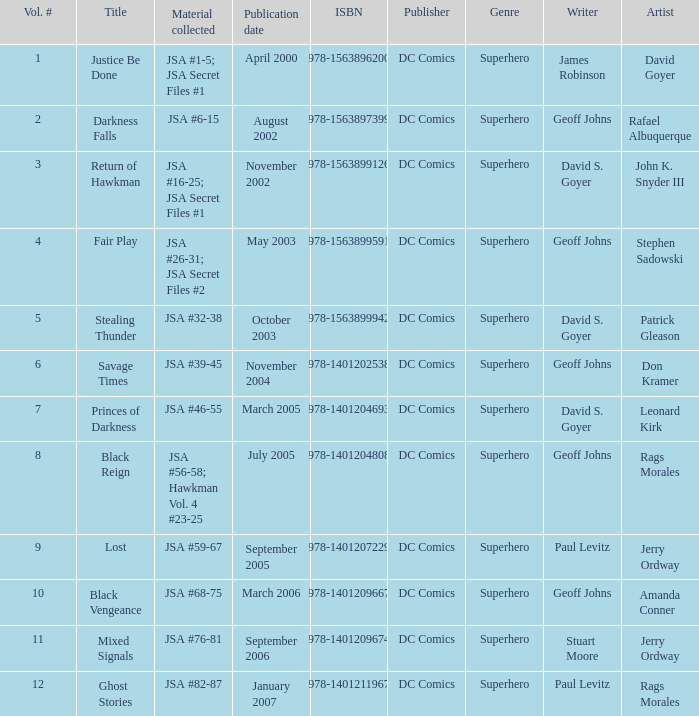What's the Lowest Volume Number that was published November 2004? 6.0. 